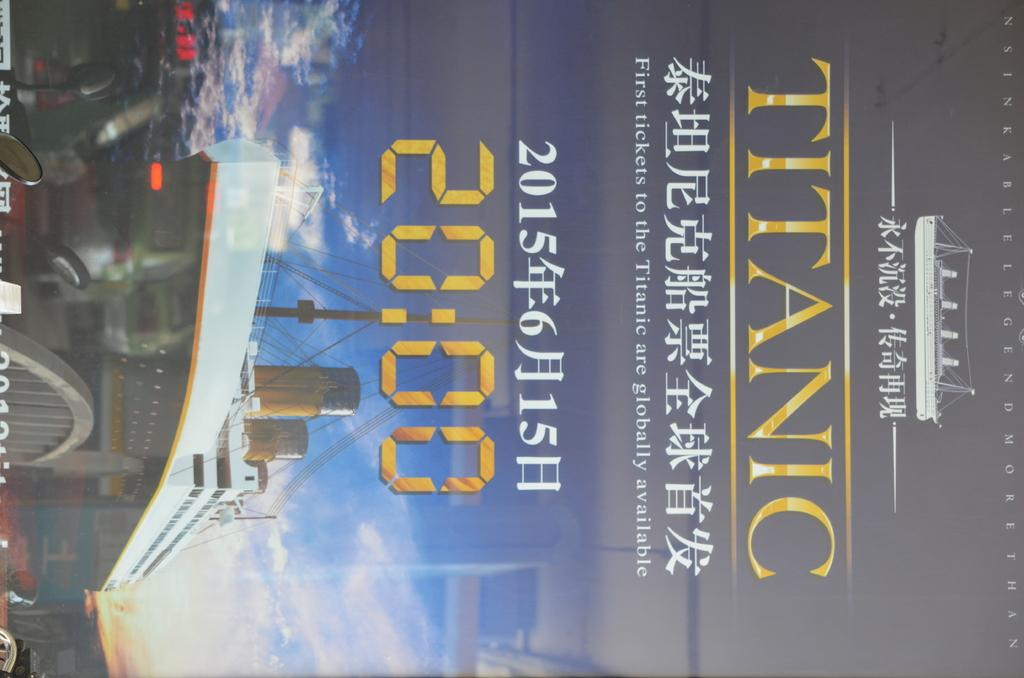<image>
Give a short and clear explanation of the subsequent image. A movie poster of the classic movie Titanic 